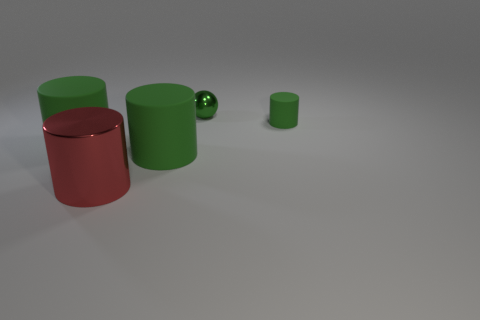What can you tell me about the lighting in this scene? The lighting in this scene appears to be diffused, with soft shadows indicating an overhead light source that is not too harsh. This kind of lighting creates a gentle ambiance and avoids harsh contrasts. 